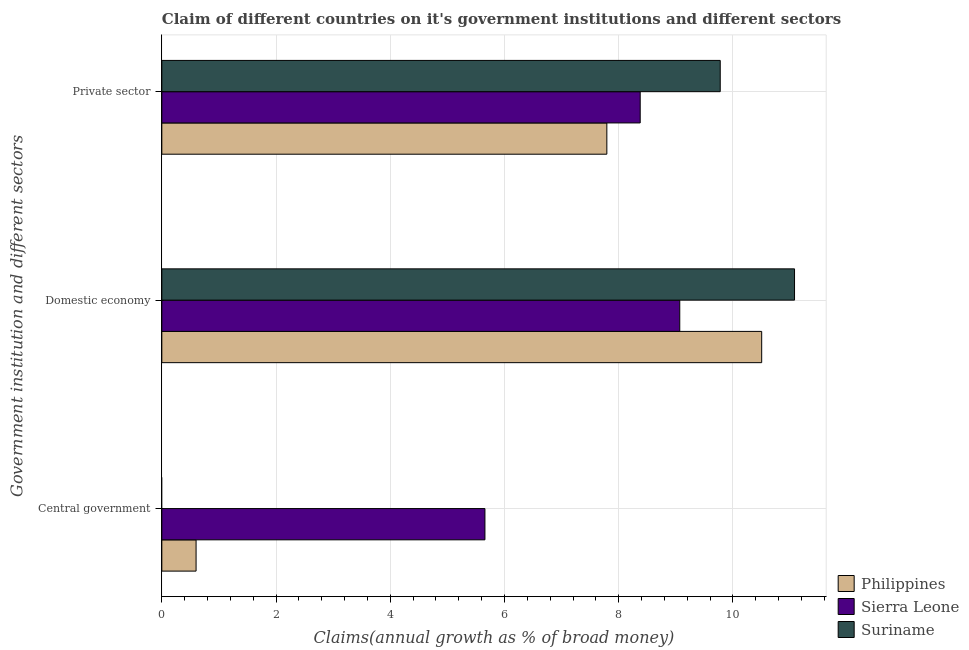How many different coloured bars are there?
Keep it short and to the point. 3. Are the number of bars per tick equal to the number of legend labels?
Your answer should be very brief. No. How many bars are there on the 1st tick from the top?
Ensure brevity in your answer.  3. How many bars are there on the 1st tick from the bottom?
Provide a short and direct response. 2. What is the label of the 1st group of bars from the top?
Keep it short and to the point. Private sector. What is the percentage of claim on the private sector in Suriname?
Keep it short and to the point. 9.78. Across all countries, what is the maximum percentage of claim on the central government?
Provide a short and direct response. 5.66. Across all countries, what is the minimum percentage of claim on the private sector?
Your response must be concise. 7.79. In which country was the percentage of claim on the private sector maximum?
Offer a terse response. Suriname. What is the total percentage of claim on the private sector in the graph?
Provide a short and direct response. 25.95. What is the difference between the percentage of claim on the private sector in Suriname and that in Philippines?
Your answer should be compact. 1.99. What is the difference between the percentage of claim on the central government in Philippines and the percentage of claim on the private sector in Suriname?
Keep it short and to the point. -9.18. What is the average percentage of claim on the private sector per country?
Offer a terse response. 8.65. What is the difference between the percentage of claim on the private sector and percentage of claim on the central government in Sierra Leone?
Ensure brevity in your answer.  2.72. In how many countries, is the percentage of claim on the private sector greater than 6.8 %?
Keep it short and to the point. 3. What is the ratio of the percentage of claim on the private sector in Suriname to that in Philippines?
Your answer should be compact. 1.25. Is the percentage of claim on the private sector in Philippines less than that in Sierra Leone?
Offer a terse response. Yes. Is the difference between the percentage of claim on the domestic economy in Philippines and Sierra Leone greater than the difference between the percentage of claim on the private sector in Philippines and Sierra Leone?
Ensure brevity in your answer.  Yes. What is the difference between the highest and the second highest percentage of claim on the private sector?
Make the answer very short. 1.4. What is the difference between the highest and the lowest percentage of claim on the private sector?
Your response must be concise. 1.99. In how many countries, is the percentage of claim on the domestic economy greater than the average percentage of claim on the domestic economy taken over all countries?
Make the answer very short. 2. Is it the case that in every country, the sum of the percentage of claim on the central government and percentage of claim on the domestic economy is greater than the percentage of claim on the private sector?
Your response must be concise. Yes. Are all the bars in the graph horizontal?
Your answer should be very brief. Yes. How many countries are there in the graph?
Your answer should be very brief. 3. What is the difference between two consecutive major ticks on the X-axis?
Your response must be concise. 2. Are the values on the major ticks of X-axis written in scientific E-notation?
Ensure brevity in your answer.  No. How are the legend labels stacked?
Your response must be concise. Vertical. What is the title of the graph?
Make the answer very short. Claim of different countries on it's government institutions and different sectors. What is the label or title of the X-axis?
Your answer should be compact. Claims(annual growth as % of broad money). What is the label or title of the Y-axis?
Ensure brevity in your answer.  Government institution and different sectors. What is the Claims(annual growth as % of broad money) of Philippines in Central government?
Your response must be concise. 0.6. What is the Claims(annual growth as % of broad money) in Sierra Leone in Central government?
Provide a succinct answer. 5.66. What is the Claims(annual growth as % of broad money) of Suriname in Central government?
Offer a terse response. 0. What is the Claims(annual growth as % of broad money) in Philippines in Domestic economy?
Your response must be concise. 10.5. What is the Claims(annual growth as % of broad money) in Sierra Leone in Domestic economy?
Ensure brevity in your answer.  9.07. What is the Claims(annual growth as % of broad money) of Suriname in Domestic economy?
Make the answer very short. 11.08. What is the Claims(annual growth as % of broad money) of Philippines in Private sector?
Ensure brevity in your answer.  7.79. What is the Claims(annual growth as % of broad money) in Sierra Leone in Private sector?
Offer a terse response. 8.38. What is the Claims(annual growth as % of broad money) in Suriname in Private sector?
Your answer should be compact. 9.78. Across all Government institution and different sectors, what is the maximum Claims(annual growth as % of broad money) of Philippines?
Your response must be concise. 10.5. Across all Government institution and different sectors, what is the maximum Claims(annual growth as % of broad money) in Sierra Leone?
Offer a terse response. 9.07. Across all Government institution and different sectors, what is the maximum Claims(annual growth as % of broad money) in Suriname?
Make the answer very short. 11.08. Across all Government institution and different sectors, what is the minimum Claims(annual growth as % of broad money) in Philippines?
Your answer should be very brief. 0.6. Across all Government institution and different sectors, what is the minimum Claims(annual growth as % of broad money) in Sierra Leone?
Give a very brief answer. 5.66. What is the total Claims(annual growth as % of broad money) in Philippines in the graph?
Offer a very short reply. 18.9. What is the total Claims(annual growth as % of broad money) of Sierra Leone in the graph?
Your answer should be compact. 23.1. What is the total Claims(annual growth as % of broad money) in Suriname in the graph?
Your answer should be compact. 20.86. What is the difference between the Claims(annual growth as % of broad money) of Philippines in Central government and that in Domestic economy?
Offer a very short reply. -9.9. What is the difference between the Claims(annual growth as % of broad money) of Sierra Leone in Central government and that in Domestic economy?
Your answer should be compact. -3.41. What is the difference between the Claims(annual growth as % of broad money) in Philippines in Central government and that in Private sector?
Offer a very short reply. -7.19. What is the difference between the Claims(annual growth as % of broad money) of Sierra Leone in Central government and that in Private sector?
Make the answer very short. -2.72. What is the difference between the Claims(annual growth as % of broad money) in Philippines in Domestic economy and that in Private sector?
Make the answer very short. 2.71. What is the difference between the Claims(annual growth as % of broad money) of Sierra Leone in Domestic economy and that in Private sector?
Ensure brevity in your answer.  0.69. What is the difference between the Claims(annual growth as % of broad money) of Suriname in Domestic economy and that in Private sector?
Your answer should be compact. 1.3. What is the difference between the Claims(annual growth as % of broad money) in Philippines in Central government and the Claims(annual growth as % of broad money) in Sierra Leone in Domestic economy?
Provide a succinct answer. -8.47. What is the difference between the Claims(annual growth as % of broad money) in Philippines in Central government and the Claims(annual growth as % of broad money) in Suriname in Domestic economy?
Give a very brief answer. -10.48. What is the difference between the Claims(annual growth as % of broad money) in Sierra Leone in Central government and the Claims(annual growth as % of broad money) in Suriname in Domestic economy?
Make the answer very short. -5.42. What is the difference between the Claims(annual growth as % of broad money) in Philippines in Central government and the Claims(annual growth as % of broad money) in Sierra Leone in Private sector?
Your answer should be compact. -7.78. What is the difference between the Claims(annual growth as % of broad money) in Philippines in Central government and the Claims(annual growth as % of broad money) in Suriname in Private sector?
Provide a succinct answer. -9.18. What is the difference between the Claims(annual growth as % of broad money) in Sierra Leone in Central government and the Claims(annual growth as % of broad money) in Suriname in Private sector?
Your answer should be compact. -4.12. What is the difference between the Claims(annual growth as % of broad money) in Philippines in Domestic economy and the Claims(annual growth as % of broad money) in Sierra Leone in Private sector?
Your answer should be compact. 2.13. What is the difference between the Claims(annual growth as % of broad money) of Philippines in Domestic economy and the Claims(annual growth as % of broad money) of Suriname in Private sector?
Make the answer very short. 0.73. What is the difference between the Claims(annual growth as % of broad money) of Sierra Leone in Domestic economy and the Claims(annual growth as % of broad money) of Suriname in Private sector?
Keep it short and to the point. -0.71. What is the average Claims(annual growth as % of broad money) in Philippines per Government institution and different sectors?
Offer a very short reply. 6.3. What is the average Claims(annual growth as % of broad money) of Sierra Leone per Government institution and different sectors?
Give a very brief answer. 7.7. What is the average Claims(annual growth as % of broad money) of Suriname per Government institution and different sectors?
Offer a very short reply. 6.95. What is the difference between the Claims(annual growth as % of broad money) in Philippines and Claims(annual growth as % of broad money) in Sierra Leone in Central government?
Make the answer very short. -5.06. What is the difference between the Claims(annual growth as % of broad money) in Philippines and Claims(annual growth as % of broad money) in Sierra Leone in Domestic economy?
Offer a terse response. 1.43. What is the difference between the Claims(annual growth as % of broad money) in Philippines and Claims(annual growth as % of broad money) in Suriname in Domestic economy?
Provide a short and direct response. -0.58. What is the difference between the Claims(annual growth as % of broad money) of Sierra Leone and Claims(annual growth as % of broad money) of Suriname in Domestic economy?
Make the answer very short. -2.01. What is the difference between the Claims(annual growth as % of broad money) of Philippines and Claims(annual growth as % of broad money) of Sierra Leone in Private sector?
Your answer should be very brief. -0.58. What is the difference between the Claims(annual growth as % of broad money) in Philippines and Claims(annual growth as % of broad money) in Suriname in Private sector?
Provide a succinct answer. -1.99. What is the difference between the Claims(annual growth as % of broad money) of Sierra Leone and Claims(annual growth as % of broad money) of Suriname in Private sector?
Offer a very short reply. -1.4. What is the ratio of the Claims(annual growth as % of broad money) in Philippines in Central government to that in Domestic economy?
Make the answer very short. 0.06. What is the ratio of the Claims(annual growth as % of broad money) in Sierra Leone in Central government to that in Domestic economy?
Ensure brevity in your answer.  0.62. What is the ratio of the Claims(annual growth as % of broad money) in Philippines in Central government to that in Private sector?
Your response must be concise. 0.08. What is the ratio of the Claims(annual growth as % of broad money) in Sierra Leone in Central government to that in Private sector?
Provide a succinct answer. 0.68. What is the ratio of the Claims(annual growth as % of broad money) of Philippines in Domestic economy to that in Private sector?
Keep it short and to the point. 1.35. What is the ratio of the Claims(annual growth as % of broad money) in Sierra Leone in Domestic economy to that in Private sector?
Offer a terse response. 1.08. What is the ratio of the Claims(annual growth as % of broad money) of Suriname in Domestic economy to that in Private sector?
Offer a very short reply. 1.13. What is the difference between the highest and the second highest Claims(annual growth as % of broad money) of Philippines?
Your answer should be compact. 2.71. What is the difference between the highest and the second highest Claims(annual growth as % of broad money) in Sierra Leone?
Make the answer very short. 0.69. What is the difference between the highest and the lowest Claims(annual growth as % of broad money) in Philippines?
Make the answer very short. 9.9. What is the difference between the highest and the lowest Claims(annual growth as % of broad money) in Sierra Leone?
Give a very brief answer. 3.41. What is the difference between the highest and the lowest Claims(annual growth as % of broad money) of Suriname?
Ensure brevity in your answer.  11.08. 